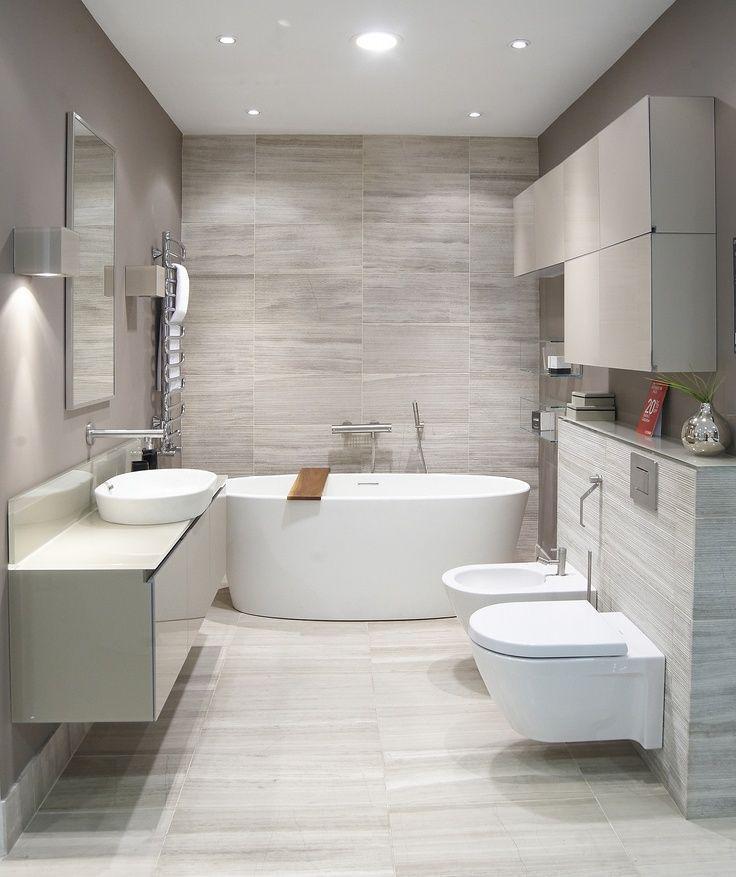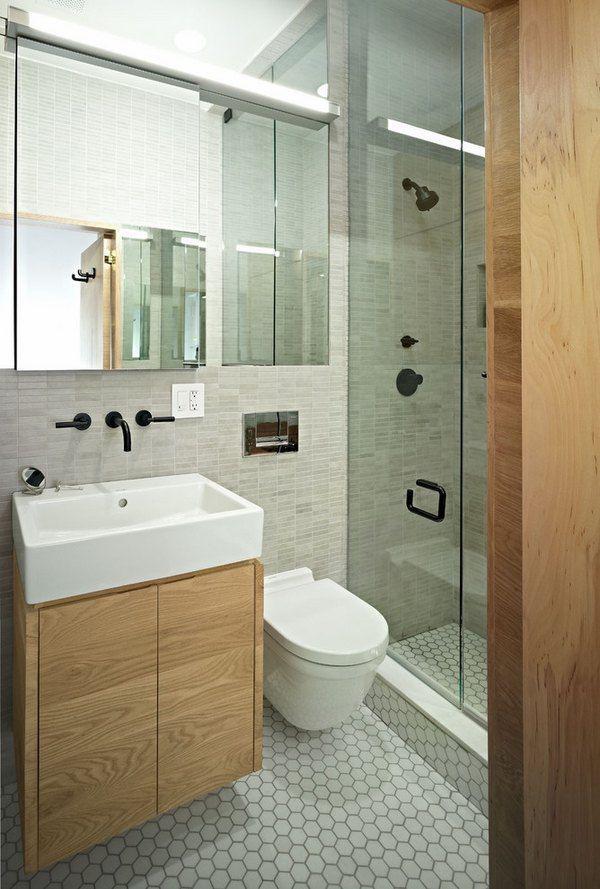The first image is the image on the left, the second image is the image on the right. For the images displayed, is the sentence "There is a bide as well as a toilet in a bathroom with at least one shelf behind it" factually correct? Answer yes or no. Yes. The first image is the image on the left, the second image is the image on the right. Examine the images to the left and right. Is the description "One of the bathrooms features a shower but no bathtub." accurate? Answer yes or no. Yes. 